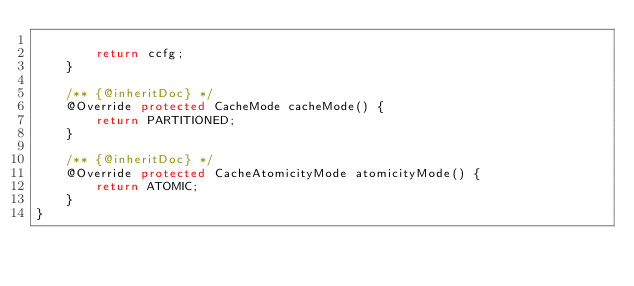Convert code to text. <code><loc_0><loc_0><loc_500><loc_500><_Java_>
        return ccfg;
    }

    /** {@inheritDoc} */
    @Override protected CacheMode cacheMode() {
        return PARTITIONED;
    }

    /** {@inheritDoc} */
    @Override protected CacheAtomicityMode atomicityMode() {
        return ATOMIC;
    }
}
</code> 